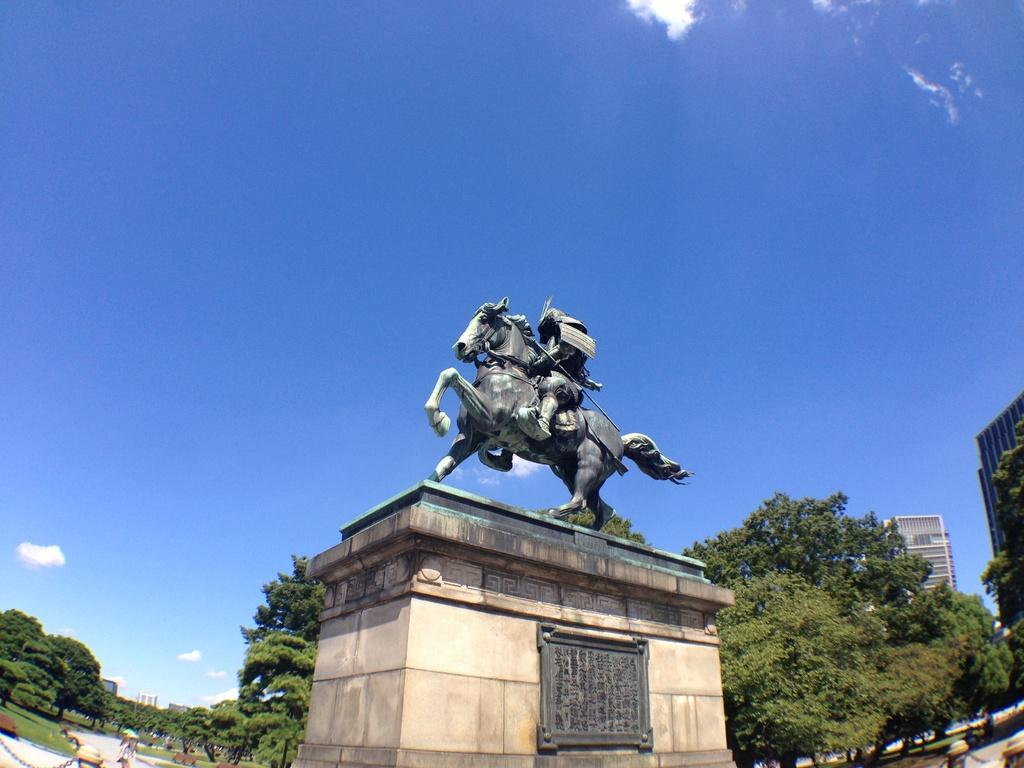What is the main subject in the middle of the image? There is a statue in the middle of the image. What can be seen in the background of the image? There are trees and buildings in the background of the image. Can you describe the person visible at the bottom of the image? There is a person visible at the bottom of the image, but their specific appearance or actions are not described in the provided facts. What word: What word is being whispered by the statue in the image? There is not present in the image, as statues are not capable of whispering words. 